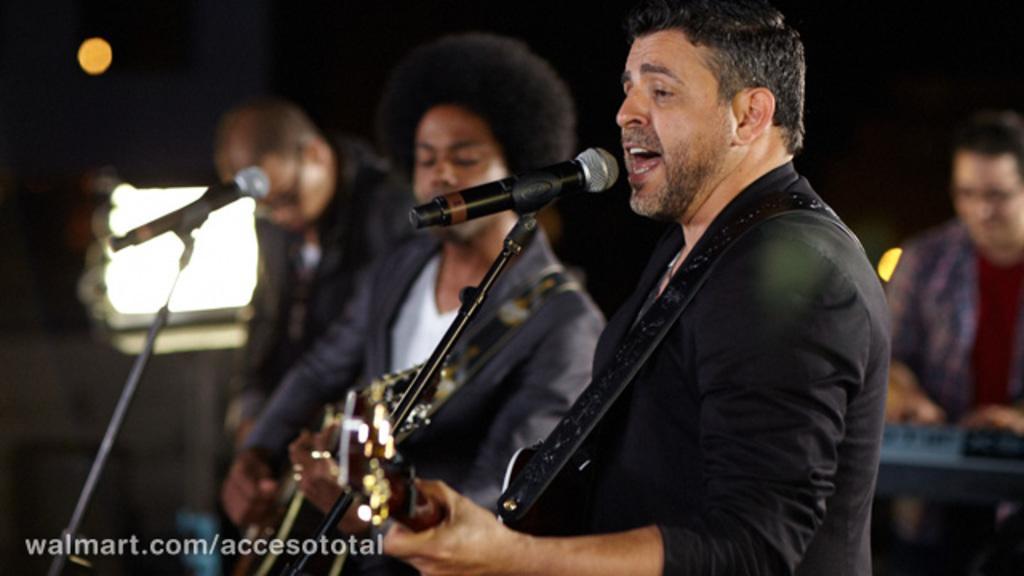In one or two sentences, can you explain what this image depicts? In this image in the foreground there are three people holding musical instruments, in front of them there are two mikes, on the right side a person holding an object, background is dark , there are some light foci in the middle, in the bottom left there is a text. 